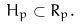Convert formula to latex. <formula><loc_0><loc_0><loc_500><loc_500>H _ { p } \subset R _ { p } .</formula> 